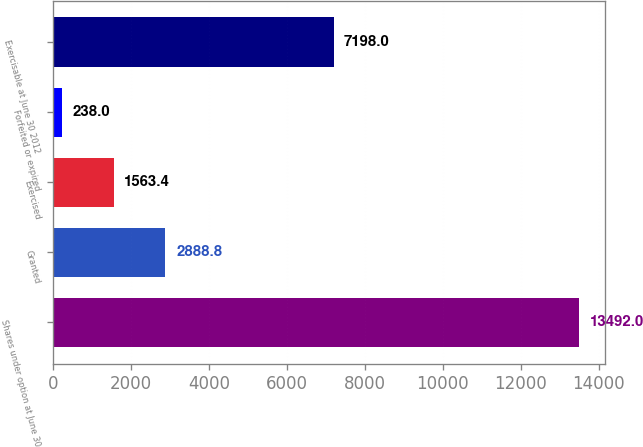Convert chart. <chart><loc_0><loc_0><loc_500><loc_500><bar_chart><fcel>Shares under option at June 30<fcel>Granted<fcel>Exercised<fcel>Forfeited or expired<fcel>Exercisable at June 30 2012<nl><fcel>13492<fcel>2888.8<fcel>1563.4<fcel>238<fcel>7198<nl></chart> 